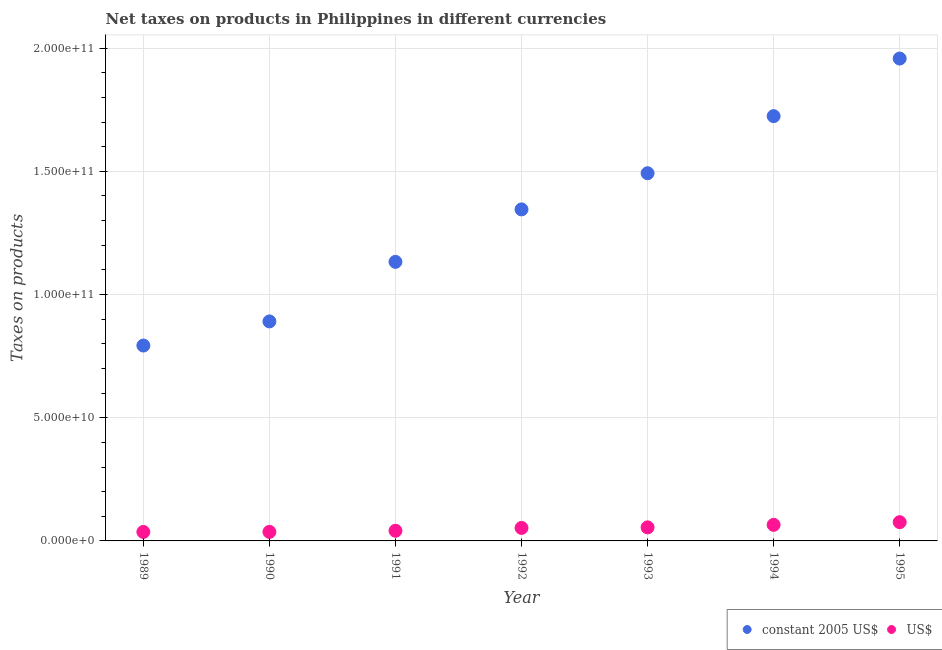Is the number of dotlines equal to the number of legend labels?
Your answer should be compact. Yes. What is the net taxes in constant 2005 us$ in 1994?
Ensure brevity in your answer.  1.72e+11. Across all years, what is the maximum net taxes in us$?
Offer a very short reply. 7.61e+09. Across all years, what is the minimum net taxes in us$?
Your answer should be very brief. 3.65e+09. What is the total net taxes in constant 2005 us$ in the graph?
Your response must be concise. 9.34e+11. What is the difference between the net taxes in constant 2005 us$ in 1989 and that in 1993?
Ensure brevity in your answer.  -6.99e+1. What is the difference between the net taxes in us$ in 1994 and the net taxes in constant 2005 us$ in 1992?
Make the answer very short. -1.28e+11. What is the average net taxes in constant 2005 us$ per year?
Your answer should be very brief. 1.33e+11. In the year 1990, what is the difference between the net taxes in us$ and net taxes in constant 2005 us$?
Your response must be concise. -8.54e+1. In how many years, is the net taxes in us$ greater than 120000000000 units?
Your response must be concise. 0. What is the ratio of the net taxes in us$ in 1989 to that in 1991?
Keep it short and to the point. 0.89. Is the difference between the net taxes in constant 2005 us$ in 1990 and 1994 greater than the difference between the net taxes in us$ in 1990 and 1994?
Your answer should be compact. No. What is the difference between the highest and the second highest net taxes in constant 2005 us$?
Your answer should be compact. 2.34e+1. What is the difference between the highest and the lowest net taxes in constant 2005 us$?
Offer a very short reply. 1.16e+11. Is the net taxes in constant 2005 us$ strictly greater than the net taxes in us$ over the years?
Give a very brief answer. Yes. How many dotlines are there?
Offer a terse response. 2. How many years are there in the graph?
Ensure brevity in your answer.  7. Where does the legend appear in the graph?
Provide a short and direct response. Bottom right. How many legend labels are there?
Make the answer very short. 2. How are the legend labels stacked?
Your answer should be compact. Horizontal. What is the title of the graph?
Provide a succinct answer. Net taxes on products in Philippines in different currencies. What is the label or title of the X-axis?
Provide a short and direct response. Year. What is the label or title of the Y-axis?
Offer a very short reply. Taxes on products. What is the Taxes on products of constant 2005 US$ in 1989?
Offer a terse response. 7.93e+1. What is the Taxes on products in US$ in 1989?
Make the answer very short. 3.65e+09. What is the Taxes on products of constant 2005 US$ in 1990?
Provide a succinct answer. 8.91e+1. What is the Taxes on products in US$ in 1990?
Provide a succinct answer. 3.66e+09. What is the Taxes on products in constant 2005 US$ in 1991?
Offer a very short reply. 1.13e+11. What is the Taxes on products of US$ in 1991?
Provide a succinct answer. 4.12e+09. What is the Taxes on products in constant 2005 US$ in 1992?
Provide a short and direct response. 1.35e+11. What is the Taxes on products of US$ in 1992?
Give a very brief answer. 5.27e+09. What is the Taxes on products of constant 2005 US$ in 1993?
Ensure brevity in your answer.  1.49e+11. What is the Taxes on products of US$ in 1993?
Your answer should be very brief. 5.50e+09. What is the Taxes on products of constant 2005 US$ in 1994?
Make the answer very short. 1.72e+11. What is the Taxes on products of US$ in 1994?
Offer a terse response. 6.53e+09. What is the Taxes on products in constant 2005 US$ in 1995?
Make the answer very short. 1.96e+11. What is the Taxes on products of US$ in 1995?
Provide a short and direct response. 7.61e+09. Across all years, what is the maximum Taxes on products in constant 2005 US$?
Your answer should be very brief. 1.96e+11. Across all years, what is the maximum Taxes on products in US$?
Provide a succinct answer. 7.61e+09. Across all years, what is the minimum Taxes on products of constant 2005 US$?
Give a very brief answer. 7.93e+1. Across all years, what is the minimum Taxes on products of US$?
Make the answer very short. 3.65e+09. What is the total Taxes on products in constant 2005 US$ in the graph?
Offer a terse response. 9.34e+11. What is the total Taxes on products of US$ in the graph?
Give a very brief answer. 3.63e+1. What is the difference between the Taxes on products of constant 2005 US$ in 1989 and that in 1990?
Provide a short and direct response. -9.79e+09. What is the difference between the Taxes on products of US$ in 1989 and that in 1990?
Make the answer very short. -1.65e+07. What is the difference between the Taxes on products in constant 2005 US$ in 1989 and that in 1991?
Your answer should be compact. -3.40e+1. What is the difference between the Taxes on products of US$ in 1989 and that in 1991?
Your answer should be very brief. -4.74e+08. What is the difference between the Taxes on products of constant 2005 US$ in 1989 and that in 1992?
Give a very brief answer. -5.53e+1. What is the difference between the Taxes on products in US$ in 1989 and that in 1992?
Your answer should be compact. -1.63e+09. What is the difference between the Taxes on products of constant 2005 US$ in 1989 and that in 1993?
Offer a very short reply. -6.99e+1. What is the difference between the Taxes on products in US$ in 1989 and that in 1993?
Your answer should be very brief. -1.85e+09. What is the difference between the Taxes on products of constant 2005 US$ in 1989 and that in 1994?
Offer a very short reply. -9.31e+1. What is the difference between the Taxes on products in US$ in 1989 and that in 1994?
Ensure brevity in your answer.  -2.88e+09. What is the difference between the Taxes on products of constant 2005 US$ in 1989 and that in 1995?
Provide a succinct answer. -1.16e+11. What is the difference between the Taxes on products in US$ in 1989 and that in 1995?
Provide a short and direct response. -3.97e+09. What is the difference between the Taxes on products in constant 2005 US$ in 1990 and that in 1991?
Offer a very short reply. -2.42e+1. What is the difference between the Taxes on products in US$ in 1990 and that in 1991?
Your answer should be very brief. -4.57e+08. What is the difference between the Taxes on products in constant 2005 US$ in 1990 and that in 1992?
Ensure brevity in your answer.  -4.55e+1. What is the difference between the Taxes on products in US$ in 1990 and that in 1992?
Offer a terse response. -1.61e+09. What is the difference between the Taxes on products of constant 2005 US$ in 1990 and that in 1993?
Make the answer very short. -6.01e+1. What is the difference between the Taxes on products of US$ in 1990 and that in 1993?
Keep it short and to the point. -1.84e+09. What is the difference between the Taxes on products in constant 2005 US$ in 1990 and that in 1994?
Offer a terse response. -8.33e+1. What is the difference between the Taxes on products in US$ in 1990 and that in 1994?
Provide a short and direct response. -2.86e+09. What is the difference between the Taxes on products in constant 2005 US$ in 1990 and that in 1995?
Your response must be concise. -1.07e+11. What is the difference between the Taxes on products in US$ in 1990 and that in 1995?
Your answer should be very brief. -3.95e+09. What is the difference between the Taxes on products of constant 2005 US$ in 1991 and that in 1992?
Keep it short and to the point. -2.13e+1. What is the difference between the Taxes on products in US$ in 1991 and that in 1992?
Ensure brevity in your answer.  -1.15e+09. What is the difference between the Taxes on products in constant 2005 US$ in 1991 and that in 1993?
Provide a short and direct response. -3.60e+1. What is the difference between the Taxes on products in US$ in 1991 and that in 1993?
Give a very brief answer. -1.38e+09. What is the difference between the Taxes on products of constant 2005 US$ in 1991 and that in 1994?
Your response must be concise. -5.91e+1. What is the difference between the Taxes on products in US$ in 1991 and that in 1994?
Ensure brevity in your answer.  -2.40e+09. What is the difference between the Taxes on products in constant 2005 US$ in 1991 and that in 1995?
Provide a short and direct response. -8.25e+1. What is the difference between the Taxes on products in US$ in 1991 and that in 1995?
Offer a very short reply. -3.49e+09. What is the difference between the Taxes on products in constant 2005 US$ in 1992 and that in 1993?
Offer a terse response. -1.47e+1. What is the difference between the Taxes on products of US$ in 1992 and that in 1993?
Provide a short and direct response. -2.29e+08. What is the difference between the Taxes on products of constant 2005 US$ in 1992 and that in 1994?
Provide a short and direct response. -3.79e+1. What is the difference between the Taxes on products in US$ in 1992 and that in 1994?
Give a very brief answer. -1.25e+09. What is the difference between the Taxes on products of constant 2005 US$ in 1992 and that in 1995?
Your answer should be compact. -6.12e+1. What is the difference between the Taxes on products in US$ in 1992 and that in 1995?
Ensure brevity in your answer.  -2.34e+09. What is the difference between the Taxes on products of constant 2005 US$ in 1993 and that in 1994?
Offer a terse response. -2.32e+1. What is the difference between the Taxes on products of US$ in 1993 and that in 1994?
Give a very brief answer. -1.02e+09. What is the difference between the Taxes on products of constant 2005 US$ in 1993 and that in 1995?
Your answer should be compact. -4.65e+1. What is the difference between the Taxes on products of US$ in 1993 and that in 1995?
Your answer should be very brief. -2.11e+09. What is the difference between the Taxes on products in constant 2005 US$ in 1994 and that in 1995?
Make the answer very short. -2.34e+1. What is the difference between the Taxes on products in US$ in 1994 and that in 1995?
Ensure brevity in your answer.  -1.09e+09. What is the difference between the Taxes on products of constant 2005 US$ in 1989 and the Taxes on products of US$ in 1990?
Provide a succinct answer. 7.56e+1. What is the difference between the Taxes on products in constant 2005 US$ in 1989 and the Taxes on products in US$ in 1991?
Make the answer very short. 7.52e+1. What is the difference between the Taxes on products of constant 2005 US$ in 1989 and the Taxes on products of US$ in 1992?
Your answer should be very brief. 7.40e+1. What is the difference between the Taxes on products of constant 2005 US$ in 1989 and the Taxes on products of US$ in 1993?
Ensure brevity in your answer.  7.38e+1. What is the difference between the Taxes on products in constant 2005 US$ in 1989 and the Taxes on products in US$ in 1994?
Your answer should be very brief. 7.28e+1. What is the difference between the Taxes on products of constant 2005 US$ in 1989 and the Taxes on products of US$ in 1995?
Offer a terse response. 7.17e+1. What is the difference between the Taxes on products in constant 2005 US$ in 1990 and the Taxes on products in US$ in 1991?
Your response must be concise. 8.50e+1. What is the difference between the Taxes on products in constant 2005 US$ in 1990 and the Taxes on products in US$ in 1992?
Your answer should be compact. 8.38e+1. What is the difference between the Taxes on products in constant 2005 US$ in 1990 and the Taxes on products in US$ in 1993?
Your answer should be very brief. 8.36e+1. What is the difference between the Taxes on products of constant 2005 US$ in 1990 and the Taxes on products of US$ in 1994?
Offer a very short reply. 8.26e+1. What is the difference between the Taxes on products of constant 2005 US$ in 1990 and the Taxes on products of US$ in 1995?
Keep it short and to the point. 8.15e+1. What is the difference between the Taxes on products of constant 2005 US$ in 1991 and the Taxes on products of US$ in 1992?
Provide a short and direct response. 1.08e+11. What is the difference between the Taxes on products in constant 2005 US$ in 1991 and the Taxes on products in US$ in 1993?
Keep it short and to the point. 1.08e+11. What is the difference between the Taxes on products of constant 2005 US$ in 1991 and the Taxes on products of US$ in 1994?
Keep it short and to the point. 1.07e+11. What is the difference between the Taxes on products in constant 2005 US$ in 1991 and the Taxes on products in US$ in 1995?
Offer a terse response. 1.06e+11. What is the difference between the Taxes on products in constant 2005 US$ in 1992 and the Taxes on products in US$ in 1993?
Your answer should be very brief. 1.29e+11. What is the difference between the Taxes on products in constant 2005 US$ in 1992 and the Taxes on products in US$ in 1994?
Offer a terse response. 1.28e+11. What is the difference between the Taxes on products of constant 2005 US$ in 1992 and the Taxes on products of US$ in 1995?
Give a very brief answer. 1.27e+11. What is the difference between the Taxes on products of constant 2005 US$ in 1993 and the Taxes on products of US$ in 1994?
Your answer should be compact. 1.43e+11. What is the difference between the Taxes on products of constant 2005 US$ in 1993 and the Taxes on products of US$ in 1995?
Give a very brief answer. 1.42e+11. What is the difference between the Taxes on products of constant 2005 US$ in 1994 and the Taxes on products of US$ in 1995?
Your answer should be very brief. 1.65e+11. What is the average Taxes on products in constant 2005 US$ per year?
Keep it short and to the point. 1.33e+11. What is the average Taxes on products of US$ per year?
Ensure brevity in your answer.  5.19e+09. In the year 1989, what is the difference between the Taxes on products in constant 2005 US$ and Taxes on products in US$?
Make the answer very short. 7.56e+1. In the year 1990, what is the difference between the Taxes on products of constant 2005 US$ and Taxes on products of US$?
Your answer should be compact. 8.54e+1. In the year 1991, what is the difference between the Taxes on products of constant 2005 US$ and Taxes on products of US$?
Your response must be concise. 1.09e+11. In the year 1992, what is the difference between the Taxes on products in constant 2005 US$ and Taxes on products in US$?
Ensure brevity in your answer.  1.29e+11. In the year 1993, what is the difference between the Taxes on products in constant 2005 US$ and Taxes on products in US$?
Your answer should be very brief. 1.44e+11. In the year 1994, what is the difference between the Taxes on products of constant 2005 US$ and Taxes on products of US$?
Offer a terse response. 1.66e+11. In the year 1995, what is the difference between the Taxes on products in constant 2005 US$ and Taxes on products in US$?
Provide a succinct answer. 1.88e+11. What is the ratio of the Taxes on products in constant 2005 US$ in 1989 to that in 1990?
Offer a very short reply. 0.89. What is the ratio of the Taxes on products in constant 2005 US$ in 1989 to that in 1991?
Provide a short and direct response. 0.7. What is the ratio of the Taxes on products of US$ in 1989 to that in 1991?
Offer a terse response. 0.89. What is the ratio of the Taxes on products in constant 2005 US$ in 1989 to that in 1992?
Provide a short and direct response. 0.59. What is the ratio of the Taxes on products in US$ in 1989 to that in 1992?
Make the answer very short. 0.69. What is the ratio of the Taxes on products of constant 2005 US$ in 1989 to that in 1993?
Offer a terse response. 0.53. What is the ratio of the Taxes on products in US$ in 1989 to that in 1993?
Your response must be concise. 0.66. What is the ratio of the Taxes on products in constant 2005 US$ in 1989 to that in 1994?
Your answer should be very brief. 0.46. What is the ratio of the Taxes on products in US$ in 1989 to that in 1994?
Offer a very short reply. 0.56. What is the ratio of the Taxes on products of constant 2005 US$ in 1989 to that in 1995?
Provide a succinct answer. 0.41. What is the ratio of the Taxes on products in US$ in 1989 to that in 1995?
Ensure brevity in your answer.  0.48. What is the ratio of the Taxes on products in constant 2005 US$ in 1990 to that in 1991?
Provide a succinct answer. 0.79. What is the ratio of the Taxes on products of US$ in 1990 to that in 1991?
Offer a very short reply. 0.89. What is the ratio of the Taxes on products of constant 2005 US$ in 1990 to that in 1992?
Make the answer very short. 0.66. What is the ratio of the Taxes on products of US$ in 1990 to that in 1992?
Keep it short and to the point. 0.69. What is the ratio of the Taxes on products of constant 2005 US$ in 1990 to that in 1993?
Provide a succinct answer. 0.6. What is the ratio of the Taxes on products in US$ in 1990 to that in 1993?
Provide a succinct answer. 0.67. What is the ratio of the Taxes on products of constant 2005 US$ in 1990 to that in 1994?
Provide a succinct answer. 0.52. What is the ratio of the Taxes on products in US$ in 1990 to that in 1994?
Provide a short and direct response. 0.56. What is the ratio of the Taxes on products of constant 2005 US$ in 1990 to that in 1995?
Your answer should be compact. 0.46. What is the ratio of the Taxes on products of US$ in 1990 to that in 1995?
Your answer should be compact. 0.48. What is the ratio of the Taxes on products of constant 2005 US$ in 1991 to that in 1992?
Your response must be concise. 0.84. What is the ratio of the Taxes on products of US$ in 1991 to that in 1992?
Your answer should be very brief. 0.78. What is the ratio of the Taxes on products in constant 2005 US$ in 1991 to that in 1993?
Your response must be concise. 0.76. What is the ratio of the Taxes on products in US$ in 1991 to that in 1993?
Ensure brevity in your answer.  0.75. What is the ratio of the Taxes on products of constant 2005 US$ in 1991 to that in 1994?
Provide a succinct answer. 0.66. What is the ratio of the Taxes on products of US$ in 1991 to that in 1994?
Offer a very short reply. 0.63. What is the ratio of the Taxes on products in constant 2005 US$ in 1991 to that in 1995?
Offer a terse response. 0.58. What is the ratio of the Taxes on products of US$ in 1991 to that in 1995?
Offer a very short reply. 0.54. What is the ratio of the Taxes on products of constant 2005 US$ in 1992 to that in 1993?
Give a very brief answer. 0.9. What is the ratio of the Taxes on products of US$ in 1992 to that in 1993?
Provide a succinct answer. 0.96. What is the ratio of the Taxes on products of constant 2005 US$ in 1992 to that in 1994?
Make the answer very short. 0.78. What is the ratio of the Taxes on products in US$ in 1992 to that in 1994?
Keep it short and to the point. 0.81. What is the ratio of the Taxes on products of constant 2005 US$ in 1992 to that in 1995?
Ensure brevity in your answer.  0.69. What is the ratio of the Taxes on products in US$ in 1992 to that in 1995?
Your answer should be very brief. 0.69. What is the ratio of the Taxes on products in constant 2005 US$ in 1993 to that in 1994?
Offer a terse response. 0.87. What is the ratio of the Taxes on products in US$ in 1993 to that in 1994?
Make the answer very short. 0.84. What is the ratio of the Taxes on products of constant 2005 US$ in 1993 to that in 1995?
Give a very brief answer. 0.76. What is the ratio of the Taxes on products in US$ in 1993 to that in 1995?
Offer a very short reply. 0.72. What is the ratio of the Taxes on products of constant 2005 US$ in 1994 to that in 1995?
Your answer should be very brief. 0.88. What is the ratio of the Taxes on products in US$ in 1994 to that in 1995?
Your answer should be very brief. 0.86. What is the difference between the highest and the second highest Taxes on products in constant 2005 US$?
Ensure brevity in your answer.  2.34e+1. What is the difference between the highest and the second highest Taxes on products of US$?
Make the answer very short. 1.09e+09. What is the difference between the highest and the lowest Taxes on products of constant 2005 US$?
Your answer should be very brief. 1.16e+11. What is the difference between the highest and the lowest Taxes on products of US$?
Keep it short and to the point. 3.97e+09. 